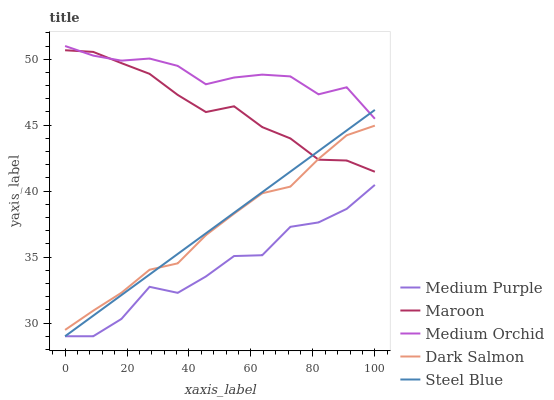Does Dark Salmon have the minimum area under the curve?
Answer yes or no. No. Does Dark Salmon have the maximum area under the curve?
Answer yes or no. No. Is Medium Orchid the smoothest?
Answer yes or no. No. Is Medium Orchid the roughest?
Answer yes or no. No. Does Dark Salmon have the lowest value?
Answer yes or no. No. Does Dark Salmon have the highest value?
Answer yes or no. No. Is Dark Salmon less than Medium Orchid?
Answer yes or no. Yes. Is Dark Salmon greater than Medium Purple?
Answer yes or no. Yes. Does Dark Salmon intersect Medium Orchid?
Answer yes or no. No. 